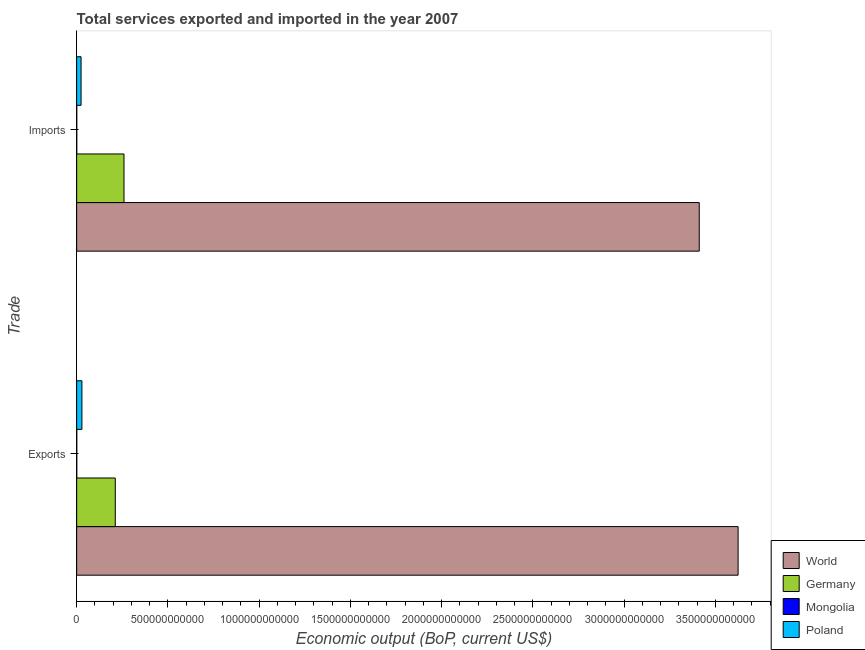How many different coloured bars are there?
Keep it short and to the point. 4. Are the number of bars per tick equal to the number of legend labels?
Provide a short and direct response. Yes. How many bars are there on the 1st tick from the top?
Make the answer very short. 4. How many bars are there on the 1st tick from the bottom?
Give a very brief answer. 4. What is the label of the 2nd group of bars from the top?
Offer a terse response. Exports. What is the amount of service exports in Mongolia?
Make the answer very short. 5.82e+08. Across all countries, what is the maximum amount of service imports?
Make the answer very short. 3.41e+12. Across all countries, what is the minimum amount of service imports?
Provide a succinct answer. 4.72e+08. In which country was the amount of service exports maximum?
Provide a succinct answer. World. In which country was the amount of service imports minimum?
Ensure brevity in your answer.  Mongolia. What is the total amount of service imports in the graph?
Keep it short and to the point. 3.70e+12. What is the difference between the amount of service exports in Poland and that in World?
Make the answer very short. -3.60e+12. What is the difference between the amount of service exports in World and the amount of service imports in Germany?
Your response must be concise. 3.36e+12. What is the average amount of service imports per country?
Ensure brevity in your answer.  9.24e+11. What is the difference between the amount of service imports and amount of service exports in Germany?
Your answer should be compact. 4.78e+1. What is the ratio of the amount of service exports in World to that in Germany?
Your answer should be compact. 17.13. In how many countries, is the amount of service exports greater than the average amount of service exports taken over all countries?
Ensure brevity in your answer.  1. What does the 4th bar from the bottom in Exports represents?
Your response must be concise. Poland. How many bars are there?
Keep it short and to the point. 8. Are all the bars in the graph horizontal?
Offer a terse response. Yes. What is the difference between two consecutive major ticks on the X-axis?
Offer a terse response. 5.00e+11. Are the values on the major ticks of X-axis written in scientific E-notation?
Make the answer very short. No. Does the graph contain any zero values?
Ensure brevity in your answer.  No. Where does the legend appear in the graph?
Your answer should be very brief. Bottom right. How are the legend labels stacked?
Provide a short and direct response. Vertical. What is the title of the graph?
Make the answer very short. Total services exported and imported in the year 2007. What is the label or title of the X-axis?
Offer a very short reply. Economic output (BoP, current US$). What is the label or title of the Y-axis?
Ensure brevity in your answer.  Trade. What is the Economic output (BoP, current US$) of World in Exports?
Ensure brevity in your answer.  3.62e+12. What is the Economic output (BoP, current US$) of Germany in Exports?
Provide a succinct answer. 2.12e+11. What is the Economic output (BoP, current US$) of Mongolia in Exports?
Give a very brief answer. 5.82e+08. What is the Economic output (BoP, current US$) in Poland in Exports?
Keep it short and to the point. 2.89e+1. What is the Economic output (BoP, current US$) of World in Imports?
Your answer should be very brief. 3.41e+12. What is the Economic output (BoP, current US$) of Germany in Imports?
Provide a short and direct response. 2.59e+11. What is the Economic output (BoP, current US$) in Mongolia in Imports?
Give a very brief answer. 4.72e+08. What is the Economic output (BoP, current US$) of Poland in Imports?
Ensure brevity in your answer.  2.42e+1. Across all Trade, what is the maximum Economic output (BoP, current US$) in World?
Ensure brevity in your answer.  3.62e+12. Across all Trade, what is the maximum Economic output (BoP, current US$) in Germany?
Your answer should be very brief. 2.59e+11. Across all Trade, what is the maximum Economic output (BoP, current US$) of Mongolia?
Provide a succinct answer. 5.82e+08. Across all Trade, what is the maximum Economic output (BoP, current US$) in Poland?
Your response must be concise. 2.89e+1. Across all Trade, what is the minimum Economic output (BoP, current US$) in World?
Ensure brevity in your answer.  3.41e+12. Across all Trade, what is the minimum Economic output (BoP, current US$) in Germany?
Make the answer very short. 2.12e+11. Across all Trade, what is the minimum Economic output (BoP, current US$) of Mongolia?
Keep it short and to the point. 4.72e+08. Across all Trade, what is the minimum Economic output (BoP, current US$) in Poland?
Give a very brief answer. 2.42e+1. What is the total Economic output (BoP, current US$) of World in the graph?
Your answer should be compact. 7.04e+12. What is the total Economic output (BoP, current US$) in Germany in the graph?
Offer a very short reply. 4.71e+11. What is the total Economic output (BoP, current US$) in Mongolia in the graph?
Keep it short and to the point. 1.05e+09. What is the total Economic output (BoP, current US$) of Poland in the graph?
Your response must be concise. 5.30e+1. What is the difference between the Economic output (BoP, current US$) in World in Exports and that in Imports?
Ensure brevity in your answer.  2.13e+11. What is the difference between the Economic output (BoP, current US$) of Germany in Exports and that in Imports?
Your answer should be very brief. -4.78e+1. What is the difference between the Economic output (BoP, current US$) in Mongolia in Exports and that in Imports?
Make the answer very short. 1.09e+08. What is the difference between the Economic output (BoP, current US$) of Poland in Exports and that in Imports?
Your answer should be very brief. 4.71e+09. What is the difference between the Economic output (BoP, current US$) of World in Exports and the Economic output (BoP, current US$) of Germany in Imports?
Your answer should be very brief. 3.36e+12. What is the difference between the Economic output (BoP, current US$) of World in Exports and the Economic output (BoP, current US$) of Mongolia in Imports?
Offer a terse response. 3.62e+12. What is the difference between the Economic output (BoP, current US$) of World in Exports and the Economic output (BoP, current US$) of Poland in Imports?
Offer a very short reply. 3.60e+12. What is the difference between the Economic output (BoP, current US$) in Germany in Exports and the Economic output (BoP, current US$) in Mongolia in Imports?
Ensure brevity in your answer.  2.11e+11. What is the difference between the Economic output (BoP, current US$) in Germany in Exports and the Economic output (BoP, current US$) in Poland in Imports?
Keep it short and to the point. 1.87e+11. What is the difference between the Economic output (BoP, current US$) of Mongolia in Exports and the Economic output (BoP, current US$) of Poland in Imports?
Your response must be concise. -2.36e+1. What is the average Economic output (BoP, current US$) in World per Trade?
Provide a short and direct response. 3.52e+12. What is the average Economic output (BoP, current US$) in Germany per Trade?
Your answer should be very brief. 2.36e+11. What is the average Economic output (BoP, current US$) in Mongolia per Trade?
Ensure brevity in your answer.  5.27e+08. What is the average Economic output (BoP, current US$) in Poland per Trade?
Provide a short and direct response. 2.65e+1. What is the difference between the Economic output (BoP, current US$) in World and Economic output (BoP, current US$) in Germany in Exports?
Give a very brief answer. 3.41e+12. What is the difference between the Economic output (BoP, current US$) in World and Economic output (BoP, current US$) in Mongolia in Exports?
Offer a terse response. 3.62e+12. What is the difference between the Economic output (BoP, current US$) in World and Economic output (BoP, current US$) in Poland in Exports?
Your answer should be compact. 3.60e+12. What is the difference between the Economic output (BoP, current US$) in Germany and Economic output (BoP, current US$) in Mongolia in Exports?
Your response must be concise. 2.11e+11. What is the difference between the Economic output (BoP, current US$) of Germany and Economic output (BoP, current US$) of Poland in Exports?
Provide a short and direct response. 1.83e+11. What is the difference between the Economic output (BoP, current US$) of Mongolia and Economic output (BoP, current US$) of Poland in Exports?
Your answer should be very brief. -2.83e+1. What is the difference between the Economic output (BoP, current US$) in World and Economic output (BoP, current US$) in Germany in Imports?
Give a very brief answer. 3.15e+12. What is the difference between the Economic output (BoP, current US$) in World and Economic output (BoP, current US$) in Mongolia in Imports?
Give a very brief answer. 3.41e+12. What is the difference between the Economic output (BoP, current US$) of World and Economic output (BoP, current US$) of Poland in Imports?
Keep it short and to the point. 3.39e+12. What is the difference between the Economic output (BoP, current US$) of Germany and Economic output (BoP, current US$) of Mongolia in Imports?
Offer a terse response. 2.59e+11. What is the difference between the Economic output (BoP, current US$) in Germany and Economic output (BoP, current US$) in Poland in Imports?
Your answer should be compact. 2.35e+11. What is the difference between the Economic output (BoP, current US$) in Mongolia and Economic output (BoP, current US$) in Poland in Imports?
Keep it short and to the point. -2.37e+1. What is the ratio of the Economic output (BoP, current US$) of World in Exports to that in Imports?
Offer a very short reply. 1.06. What is the ratio of the Economic output (BoP, current US$) in Germany in Exports to that in Imports?
Give a very brief answer. 0.82. What is the ratio of the Economic output (BoP, current US$) in Mongolia in Exports to that in Imports?
Your answer should be compact. 1.23. What is the ratio of the Economic output (BoP, current US$) in Poland in Exports to that in Imports?
Provide a short and direct response. 1.2. What is the difference between the highest and the second highest Economic output (BoP, current US$) in World?
Keep it short and to the point. 2.13e+11. What is the difference between the highest and the second highest Economic output (BoP, current US$) of Germany?
Give a very brief answer. 4.78e+1. What is the difference between the highest and the second highest Economic output (BoP, current US$) of Mongolia?
Your answer should be compact. 1.09e+08. What is the difference between the highest and the second highest Economic output (BoP, current US$) in Poland?
Provide a short and direct response. 4.71e+09. What is the difference between the highest and the lowest Economic output (BoP, current US$) of World?
Keep it short and to the point. 2.13e+11. What is the difference between the highest and the lowest Economic output (BoP, current US$) of Germany?
Provide a short and direct response. 4.78e+1. What is the difference between the highest and the lowest Economic output (BoP, current US$) in Mongolia?
Your answer should be compact. 1.09e+08. What is the difference between the highest and the lowest Economic output (BoP, current US$) of Poland?
Provide a short and direct response. 4.71e+09. 